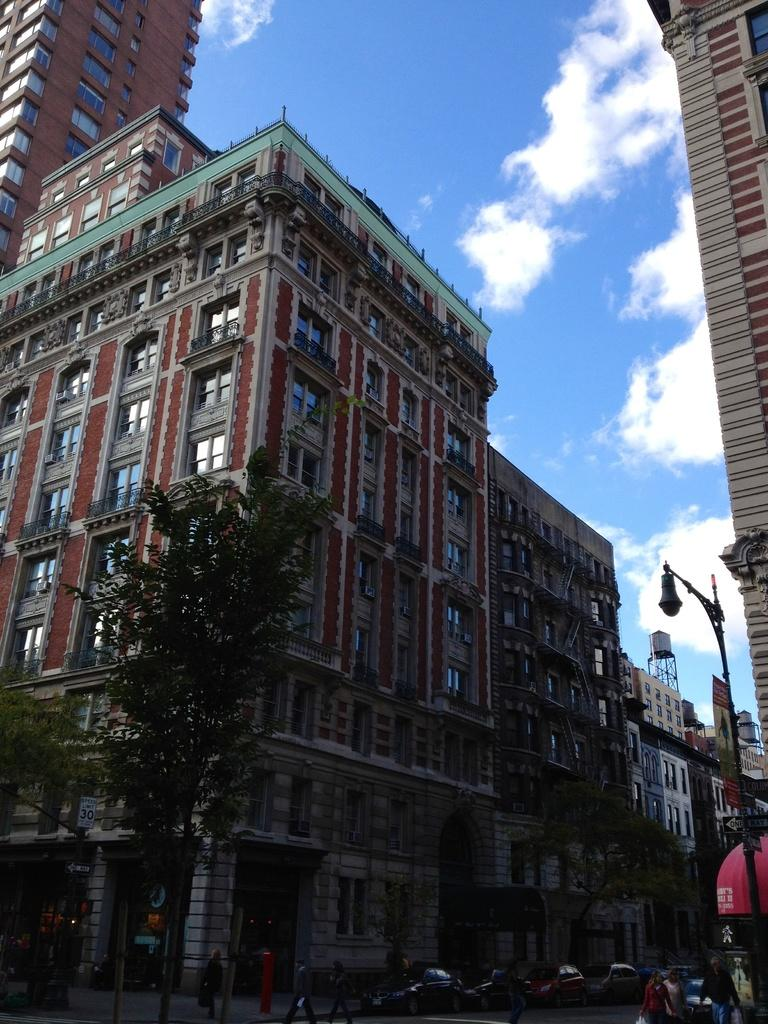What type of structures can be seen in the image? There are buildings in the image. What other natural elements are present in the image? There are trees in the image. What type of man-made objects can be seen in the image? There are vehicles in the image. What type of lighting fixture is present in the image? There is a street light in the image. Can you see any grains of dust on the vehicles in the image? There is no mention of dust or grains on the vehicles in the image, so we cannot determine their presence. Is there a goat visible in the image? There is no mention of a goat in the image, so we cannot determine its presence. 